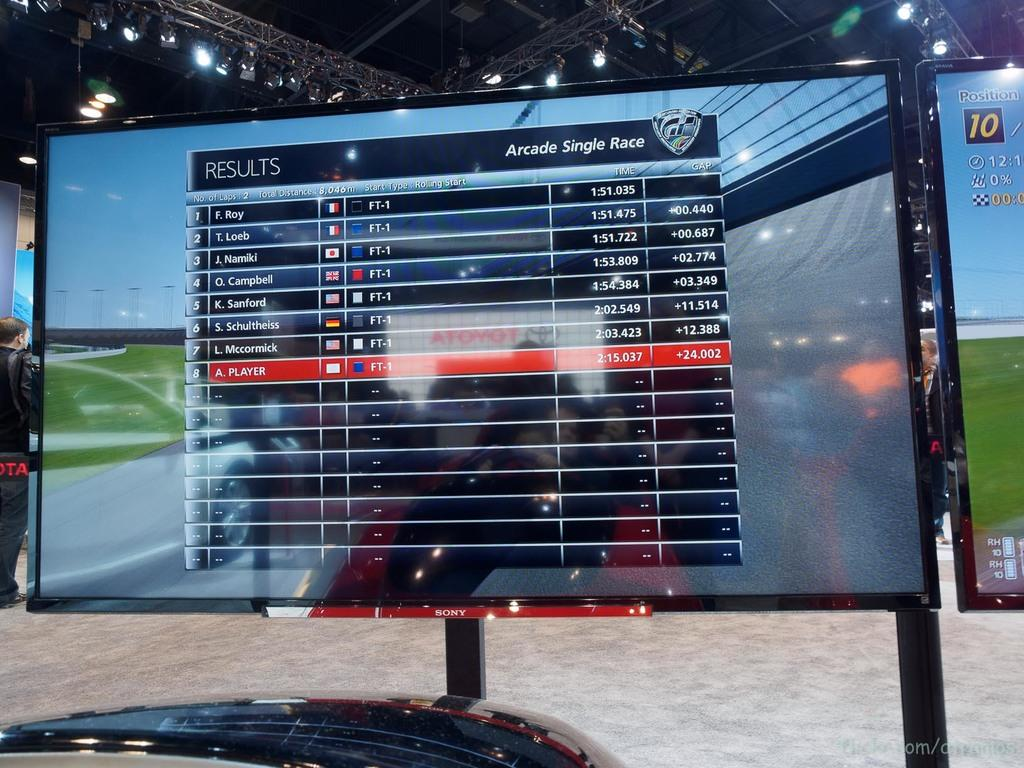<image>
Summarize the visual content of the image. A monitor displays a grid with"results" in the left corner. 